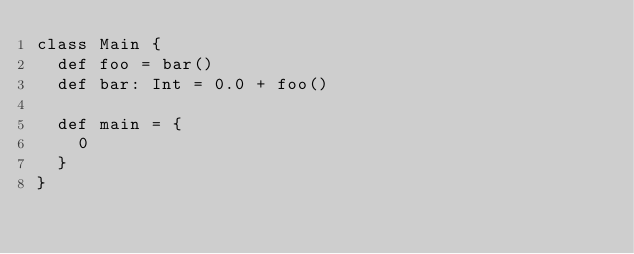<code> <loc_0><loc_0><loc_500><loc_500><_Scala_>class Main {
  def foo = bar()
  def bar: Int = 0.0 + foo()

  def main = {
    0
  }
}</code> 